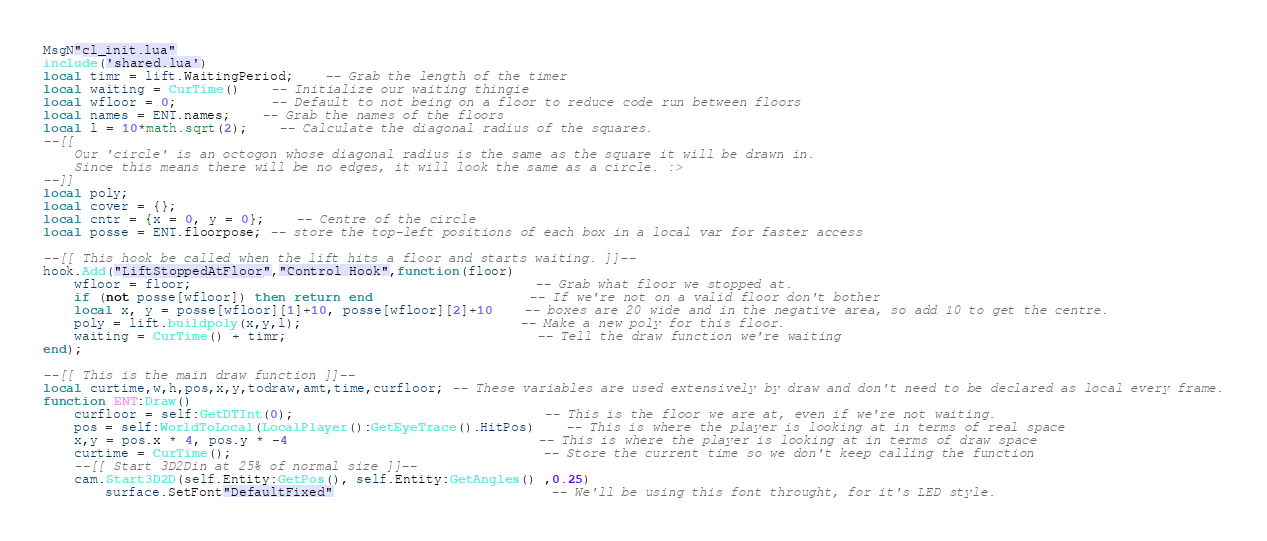<code> <loc_0><loc_0><loc_500><loc_500><_Lua_>MsgN"cl_init.lua"
include('shared.lua')
local timr = lift.WaitingPeriod;	-- Grab the length of the timer
local waiting = CurTime()	-- Initialize our waiting thingie
local wfloor = 0;			-- Default to not being on a floor to reduce code run between floors
local names = ENT.names;	-- Grab the names of the floors
local l = 10*math.sqrt(2);	-- Calculate the diagonal radius of the squares.
--[[
	Our 'circle' is an octogon whose diagonal radius is the same as the square it will be drawn in.
	Since this means there will be no edges, it will look the same as a circle. :>
--]]
local poly;
local cover = {};
local cntr = {x = 0, y = 0};	-- Centre of the circle
local posse = ENT.floorpose; -- store the top-left positions of each box in a local var for faster access

--[[ This hook be called when the lift hits a floor and starts waiting. ]]--
hook.Add("LiftStoppedAtFloor","Control Hook",function(floor)
	wfloor = floor;											-- Grab what floor we stopped at.
	if (not posse[wfloor]) then return end					-- If we're not on a valid floor don't bother
	local x, y = posse[wfloor][1]+10, posse[wfloor][2]+10	-- boxes are 20 wide and in the negative area, so add 10 to get the centre.
	poly = lift.buildpoly(x,y,l);							-- Make a new poly for this floor.
	waiting = CurTime() + timr;								-- Tell the draw function we're waiting
end);

--[[ This is the main draw function ]]--
local curtime,w,h,pos,x,y,todraw,amt,time,curfloor; -- These variables are used extensively by draw and don't need to be declared as local every frame.
function ENT:Draw()
	curfloor = self:GetDTInt(0);								-- This is the floor we are at, even if we're not waiting.
	pos = self:WorldToLocal(LocalPlayer():GetEyeTrace().HitPos)	-- This is where the player is looking at in terms of real space
	x,y = pos.x * 4, pos.y * -4 								-- This is where the player is looking at in terms of draw space
	curtime = CurTime();										-- Store the current time so we don't keep calling the function
	--[[ Start 3D2Din at 25% of normal size ]]--
	cam.Start3D2D(self.Entity:GetPos(), self.Entity:GetAngles() ,0.25)
		surface.SetFont"DefaultFixed"							-- We'll be using this font throught, for it's LED style.</code> 